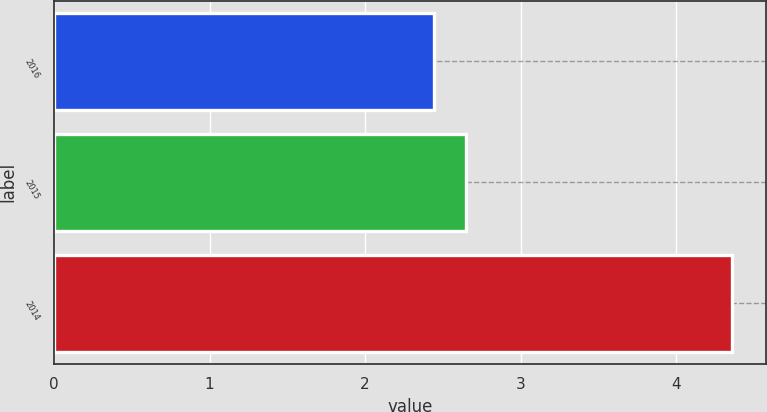Convert chart to OTSL. <chart><loc_0><loc_0><loc_500><loc_500><bar_chart><fcel>2016<fcel>2015<fcel>2014<nl><fcel>2.44<fcel>2.65<fcel>4.36<nl></chart> 